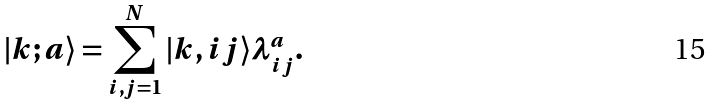<formula> <loc_0><loc_0><loc_500><loc_500>| k ; a \rangle = \sum _ { i , j = 1 } ^ { N } | k , i j \rangle \lambda _ { i j } ^ { a } .</formula> 